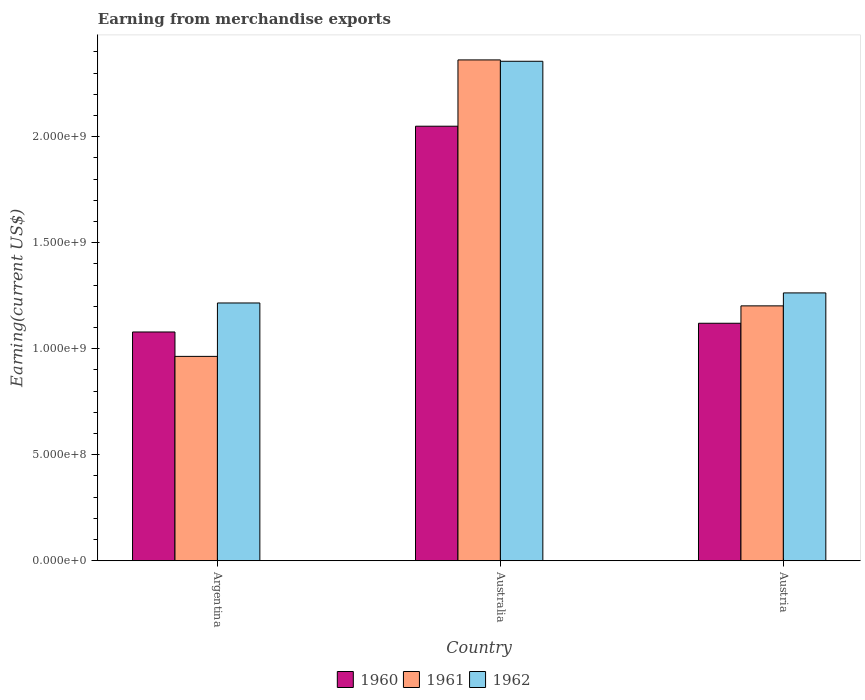Are the number of bars per tick equal to the number of legend labels?
Your response must be concise. Yes. Are the number of bars on each tick of the X-axis equal?
Keep it short and to the point. Yes. In how many cases, is the number of bars for a given country not equal to the number of legend labels?
Provide a short and direct response. 0. What is the amount earned from merchandise exports in 1961 in Argentina?
Offer a very short reply. 9.64e+08. Across all countries, what is the maximum amount earned from merchandise exports in 1960?
Make the answer very short. 2.05e+09. Across all countries, what is the minimum amount earned from merchandise exports in 1960?
Make the answer very short. 1.08e+09. In which country was the amount earned from merchandise exports in 1962 minimum?
Give a very brief answer. Argentina. What is the total amount earned from merchandise exports in 1960 in the graph?
Your response must be concise. 4.25e+09. What is the difference between the amount earned from merchandise exports in 1961 in Australia and that in Austria?
Your response must be concise. 1.16e+09. What is the difference between the amount earned from merchandise exports in 1960 in Australia and the amount earned from merchandise exports in 1961 in Austria?
Make the answer very short. 8.47e+08. What is the average amount earned from merchandise exports in 1961 per country?
Keep it short and to the point. 1.51e+09. What is the difference between the amount earned from merchandise exports of/in 1961 and amount earned from merchandise exports of/in 1960 in Austria?
Provide a short and direct response. 8.20e+07. In how many countries, is the amount earned from merchandise exports in 1961 greater than 1700000000 US$?
Offer a very short reply. 1. What is the ratio of the amount earned from merchandise exports in 1962 in Australia to that in Austria?
Your answer should be very brief. 1.86. Is the amount earned from merchandise exports in 1960 in Australia less than that in Austria?
Provide a succinct answer. No. What is the difference between the highest and the second highest amount earned from merchandise exports in 1960?
Your response must be concise. 9.71e+08. What is the difference between the highest and the lowest amount earned from merchandise exports in 1961?
Offer a terse response. 1.40e+09. In how many countries, is the amount earned from merchandise exports in 1961 greater than the average amount earned from merchandise exports in 1961 taken over all countries?
Give a very brief answer. 1. Is the sum of the amount earned from merchandise exports in 1960 in Argentina and Austria greater than the maximum amount earned from merchandise exports in 1961 across all countries?
Your answer should be compact. No. What does the 3rd bar from the left in Argentina represents?
Give a very brief answer. 1962. Is it the case that in every country, the sum of the amount earned from merchandise exports in 1962 and amount earned from merchandise exports in 1961 is greater than the amount earned from merchandise exports in 1960?
Offer a terse response. Yes. What is the difference between two consecutive major ticks on the Y-axis?
Offer a very short reply. 5.00e+08. Does the graph contain any zero values?
Provide a succinct answer. No. Does the graph contain grids?
Make the answer very short. No. Where does the legend appear in the graph?
Offer a terse response. Bottom center. How many legend labels are there?
Give a very brief answer. 3. How are the legend labels stacked?
Your answer should be very brief. Horizontal. What is the title of the graph?
Keep it short and to the point. Earning from merchandise exports. Does "1973" appear as one of the legend labels in the graph?
Provide a succinct answer. No. What is the label or title of the Y-axis?
Keep it short and to the point. Earning(current US$). What is the Earning(current US$) in 1960 in Argentina?
Offer a very short reply. 1.08e+09. What is the Earning(current US$) in 1961 in Argentina?
Your answer should be very brief. 9.64e+08. What is the Earning(current US$) of 1962 in Argentina?
Your answer should be compact. 1.22e+09. What is the Earning(current US$) in 1960 in Australia?
Keep it short and to the point. 2.05e+09. What is the Earning(current US$) of 1961 in Australia?
Keep it short and to the point. 2.36e+09. What is the Earning(current US$) in 1962 in Australia?
Give a very brief answer. 2.36e+09. What is the Earning(current US$) of 1960 in Austria?
Your answer should be very brief. 1.12e+09. What is the Earning(current US$) of 1961 in Austria?
Your response must be concise. 1.20e+09. What is the Earning(current US$) in 1962 in Austria?
Offer a very short reply. 1.26e+09. Across all countries, what is the maximum Earning(current US$) in 1960?
Keep it short and to the point. 2.05e+09. Across all countries, what is the maximum Earning(current US$) of 1961?
Your answer should be compact. 2.36e+09. Across all countries, what is the maximum Earning(current US$) of 1962?
Offer a very short reply. 2.36e+09. Across all countries, what is the minimum Earning(current US$) of 1960?
Make the answer very short. 1.08e+09. Across all countries, what is the minimum Earning(current US$) in 1961?
Your answer should be compact. 9.64e+08. Across all countries, what is the minimum Earning(current US$) in 1962?
Your answer should be compact. 1.22e+09. What is the total Earning(current US$) of 1960 in the graph?
Offer a terse response. 4.25e+09. What is the total Earning(current US$) in 1961 in the graph?
Provide a succinct answer. 4.53e+09. What is the total Earning(current US$) of 1962 in the graph?
Your answer should be compact. 4.84e+09. What is the difference between the Earning(current US$) in 1960 in Argentina and that in Australia?
Your answer should be very brief. -9.71e+08. What is the difference between the Earning(current US$) of 1961 in Argentina and that in Australia?
Offer a terse response. -1.40e+09. What is the difference between the Earning(current US$) of 1962 in Argentina and that in Australia?
Your answer should be compact. -1.14e+09. What is the difference between the Earning(current US$) of 1960 in Argentina and that in Austria?
Your answer should be compact. -4.12e+07. What is the difference between the Earning(current US$) in 1961 in Argentina and that in Austria?
Your answer should be compact. -2.38e+08. What is the difference between the Earning(current US$) of 1962 in Argentina and that in Austria?
Keep it short and to the point. -4.75e+07. What is the difference between the Earning(current US$) of 1960 in Australia and that in Austria?
Your answer should be very brief. 9.29e+08. What is the difference between the Earning(current US$) of 1961 in Australia and that in Austria?
Your response must be concise. 1.16e+09. What is the difference between the Earning(current US$) of 1962 in Australia and that in Austria?
Your answer should be compact. 1.09e+09. What is the difference between the Earning(current US$) of 1960 in Argentina and the Earning(current US$) of 1961 in Australia?
Offer a very short reply. -1.28e+09. What is the difference between the Earning(current US$) in 1960 in Argentina and the Earning(current US$) in 1962 in Australia?
Your response must be concise. -1.28e+09. What is the difference between the Earning(current US$) of 1961 in Argentina and the Earning(current US$) of 1962 in Australia?
Give a very brief answer. -1.39e+09. What is the difference between the Earning(current US$) of 1960 in Argentina and the Earning(current US$) of 1961 in Austria?
Your answer should be very brief. -1.23e+08. What is the difference between the Earning(current US$) of 1960 in Argentina and the Earning(current US$) of 1962 in Austria?
Give a very brief answer. -1.84e+08. What is the difference between the Earning(current US$) in 1961 in Argentina and the Earning(current US$) in 1962 in Austria?
Your answer should be very brief. -2.99e+08. What is the difference between the Earning(current US$) in 1960 in Australia and the Earning(current US$) in 1961 in Austria?
Offer a terse response. 8.47e+08. What is the difference between the Earning(current US$) in 1960 in Australia and the Earning(current US$) in 1962 in Austria?
Keep it short and to the point. 7.86e+08. What is the difference between the Earning(current US$) of 1961 in Australia and the Earning(current US$) of 1962 in Austria?
Make the answer very short. 1.10e+09. What is the average Earning(current US$) in 1960 per country?
Keep it short and to the point. 1.42e+09. What is the average Earning(current US$) in 1961 per country?
Offer a terse response. 1.51e+09. What is the average Earning(current US$) in 1962 per country?
Your answer should be compact. 1.61e+09. What is the difference between the Earning(current US$) of 1960 and Earning(current US$) of 1961 in Argentina?
Offer a very short reply. 1.15e+08. What is the difference between the Earning(current US$) of 1960 and Earning(current US$) of 1962 in Argentina?
Provide a succinct answer. -1.37e+08. What is the difference between the Earning(current US$) of 1961 and Earning(current US$) of 1962 in Argentina?
Keep it short and to the point. -2.52e+08. What is the difference between the Earning(current US$) of 1960 and Earning(current US$) of 1961 in Australia?
Provide a succinct answer. -3.13e+08. What is the difference between the Earning(current US$) of 1960 and Earning(current US$) of 1962 in Australia?
Your answer should be very brief. -3.06e+08. What is the difference between the Earning(current US$) of 1961 and Earning(current US$) of 1962 in Australia?
Ensure brevity in your answer.  6.39e+06. What is the difference between the Earning(current US$) in 1960 and Earning(current US$) in 1961 in Austria?
Provide a succinct answer. -8.20e+07. What is the difference between the Earning(current US$) of 1960 and Earning(current US$) of 1962 in Austria?
Your response must be concise. -1.43e+08. What is the difference between the Earning(current US$) of 1961 and Earning(current US$) of 1962 in Austria?
Keep it short and to the point. -6.11e+07. What is the ratio of the Earning(current US$) in 1960 in Argentina to that in Australia?
Your response must be concise. 0.53. What is the ratio of the Earning(current US$) in 1961 in Argentina to that in Australia?
Ensure brevity in your answer.  0.41. What is the ratio of the Earning(current US$) in 1962 in Argentina to that in Australia?
Your answer should be very brief. 0.52. What is the ratio of the Earning(current US$) of 1960 in Argentina to that in Austria?
Your answer should be very brief. 0.96. What is the ratio of the Earning(current US$) in 1961 in Argentina to that in Austria?
Provide a succinct answer. 0.8. What is the ratio of the Earning(current US$) of 1962 in Argentina to that in Austria?
Your answer should be very brief. 0.96. What is the ratio of the Earning(current US$) of 1960 in Australia to that in Austria?
Your answer should be very brief. 1.83. What is the ratio of the Earning(current US$) of 1961 in Australia to that in Austria?
Keep it short and to the point. 1.96. What is the ratio of the Earning(current US$) of 1962 in Australia to that in Austria?
Provide a short and direct response. 1.86. What is the difference between the highest and the second highest Earning(current US$) of 1960?
Provide a succinct answer. 9.29e+08. What is the difference between the highest and the second highest Earning(current US$) in 1961?
Keep it short and to the point. 1.16e+09. What is the difference between the highest and the second highest Earning(current US$) in 1962?
Keep it short and to the point. 1.09e+09. What is the difference between the highest and the lowest Earning(current US$) in 1960?
Offer a terse response. 9.71e+08. What is the difference between the highest and the lowest Earning(current US$) of 1961?
Give a very brief answer. 1.40e+09. What is the difference between the highest and the lowest Earning(current US$) in 1962?
Give a very brief answer. 1.14e+09. 